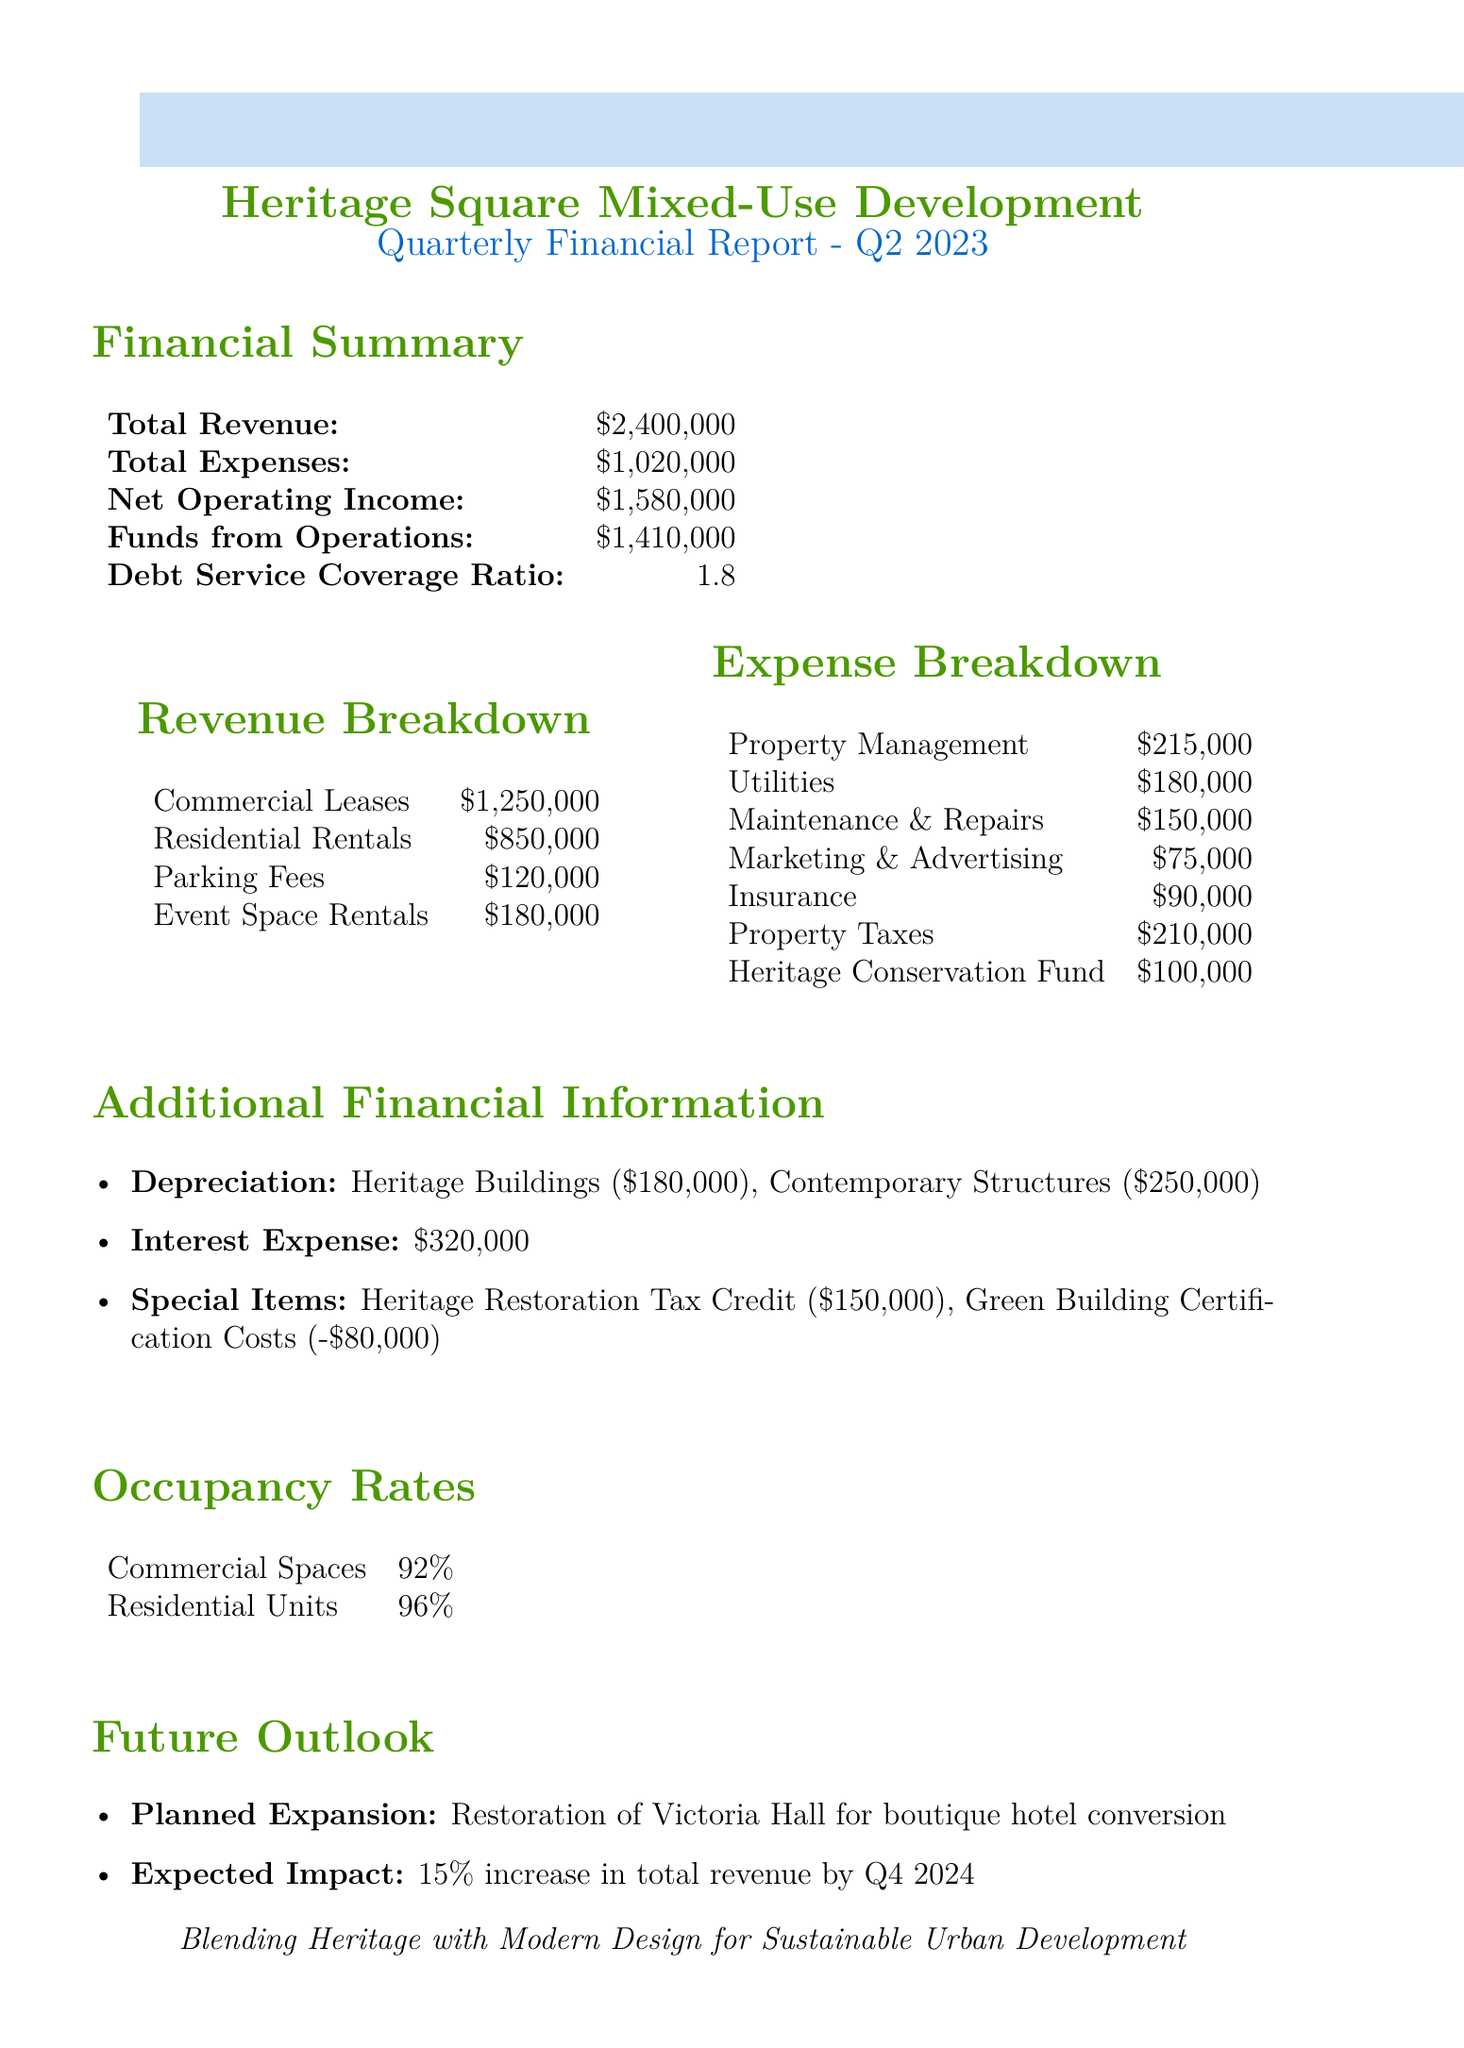what is the total revenue? The total revenue is calculated by adding all revenue sources together: commercial leases, residential rentals, parking fees, and event space rentals, amounting to $1,250,000 + $850,000 + $120,000 + $180,000.
Answer: $2,400,000 what are the residential rental earnings? The residential rental earnings can be found in the revenue section of the document, indicating the total amount received from residential rentals.
Answer: $850,000 how much was spent on property management? The expense for property management is detailed in the expense breakdown showing the allocated amount for property management services.
Answer: $215,000 what is the debt service coverage ratio? The debt service coverage ratio is a key financial metric found in the financial summary of the report, representing the project's capacity to cover its debt obligations.
Answer: 1.8 what is the expected revenue increase by Q4 2024? The expected revenue increase is mentioned in the future outlook section, where it specifies the anticipated percentage increase in total revenue following a planned expansion.
Answer: 15% how much funding is allocated to the heritage conservation fund? The document specifies the financial allocation devoted to the heritage conservation fund as part of the expenses, highlighting its importance in maintaining heritage aspects within the project.
Answer: $100,000 what is the occupancy rate for residential units? The occupancy rate for residential units can be found in the occupancy rates section, showing the percentage of occupied residential spaces in the project.
Answer: 96% what is the amount of interest expense reported? The interest expense is detailed in the additional financial information of the report, indicating the total interest costs incurred for the quarter.
Answer: $320,000 what special item had a negative cost? The special item with a negative cost indicates a deduction from the total revenue or returns in the special items section of the report, showing financial costs incurred for green certification.
Answer: Green building certification costs 